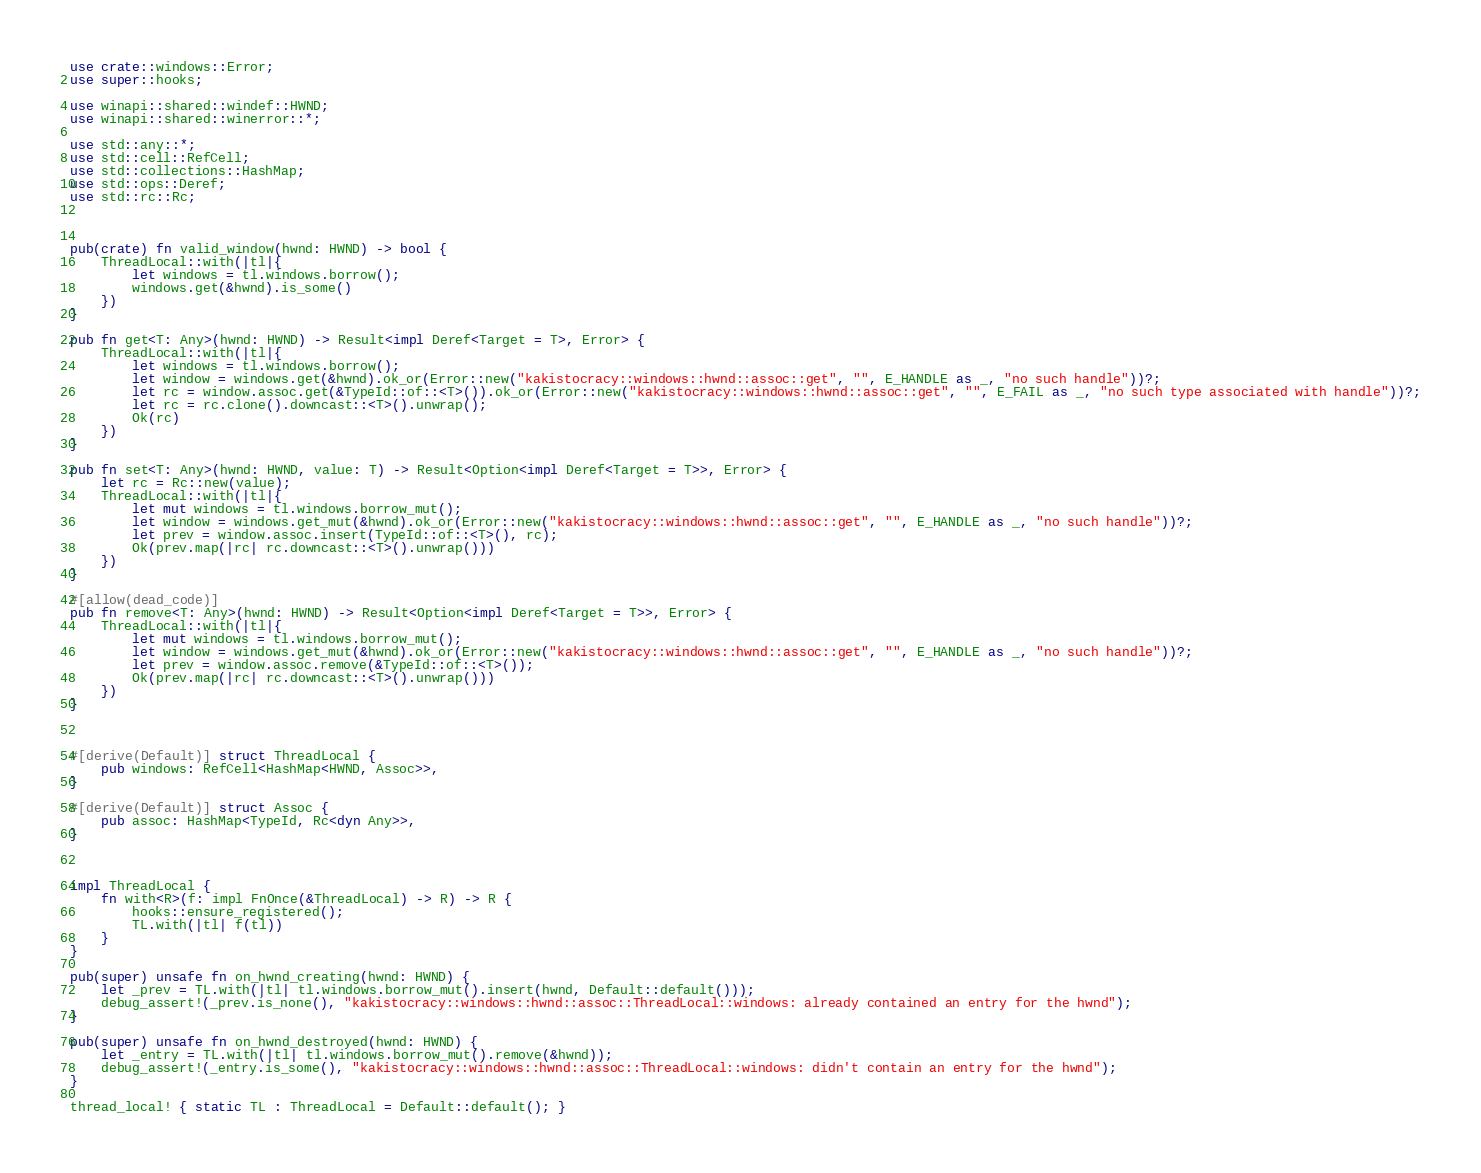<code> <loc_0><loc_0><loc_500><loc_500><_Rust_>use crate::windows::Error;
use super::hooks;

use winapi::shared::windef::HWND;
use winapi::shared::winerror::*;

use std::any::*;
use std::cell::RefCell;
use std::collections::HashMap;
use std::ops::Deref;
use std::rc::Rc;



pub(crate) fn valid_window(hwnd: HWND) -> bool {
    ThreadLocal::with(|tl|{
        let windows = tl.windows.borrow();
        windows.get(&hwnd).is_some()
    })
}

pub fn get<T: Any>(hwnd: HWND) -> Result<impl Deref<Target = T>, Error> {
    ThreadLocal::with(|tl|{
        let windows = tl.windows.borrow();
        let window = windows.get(&hwnd).ok_or(Error::new("kakistocracy::windows::hwnd::assoc::get", "", E_HANDLE as _, "no such handle"))?;
        let rc = window.assoc.get(&TypeId::of::<T>()).ok_or(Error::new("kakistocracy::windows::hwnd::assoc::get", "", E_FAIL as _, "no such type associated with handle"))?;
        let rc = rc.clone().downcast::<T>().unwrap();
        Ok(rc)
    })
}

pub fn set<T: Any>(hwnd: HWND, value: T) -> Result<Option<impl Deref<Target = T>>, Error> {
    let rc = Rc::new(value);
    ThreadLocal::with(|tl|{
        let mut windows = tl.windows.borrow_mut();
        let window = windows.get_mut(&hwnd).ok_or(Error::new("kakistocracy::windows::hwnd::assoc::get", "", E_HANDLE as _, "no such handle"))?;
        let prev = window.assoc.insert(TypeId::of::<T>(), rc);
        Ok(prev.map(|rc| rc.downcast::<T>().unwrap()))
    })
}

#[allow(dead_code)]
pub fn remove<T: Any>(hwnd: HWND) -> Result<Option<impl Deref<Target = T>>, Error> {
    ThreadLocal::with(|tl|{
        let mut windows = tl.windows.borrow_mut();
        let window = windows.get_mut(&hwnd).ok_or(Error::new("kakistocracy::windows::hwnd::assoc::get", "", E_HANDLE as _, "no such handle"))?;
        let prev = window.assoc.remove(&TypeId::of::<T>());
        Ok(prev.map(|rc| rc.downcast::<T>().unwrap()))
    })
}



#[derive(Default)] struct ThreadLocal {
    pub windows: RefCell<HashMap<HWND, Assoc>>,
}

#[derive(Default)] struct Assoc {
    pub assoc: HashMap<TypeId, Rc<dyn Any>>,
}



impl ThreadLocal {
    fn with<R>(f: impl FnOnce(&ThreadLocal) -> R) -> R {
        hooks::ensure_registered();
        TL.with(|tl| f(tl))
    }
}

pub(super) unsafe fn on_hwnd_creating(hwnd: HWND) {
    let _prev = TL.with(|tl| tl.windows.borrow_mut().insert(hwnd, Default::default()));
    debug_assert!(_prev.is_none(), "kakistocracy::windows::hwnd::assoc::ThreadLocal::windows: already contained an entry for the hwnd");
}

pub(super) unsafe fn on_hwnd_destroyed(hwnd: HWND) {
    let _entry = TL.with(|tl| tl.windows.borrow_mut().remove(&hwnd));
    debug_assert!(_entry.is_some(), "kakistocracy::windows::hwnd::assoc::ThreadLocal::windows: didn't contain an entry for the hwnd");
}

thread_local! { static TL : ThreadLocal = Default::default(); }
</code> 